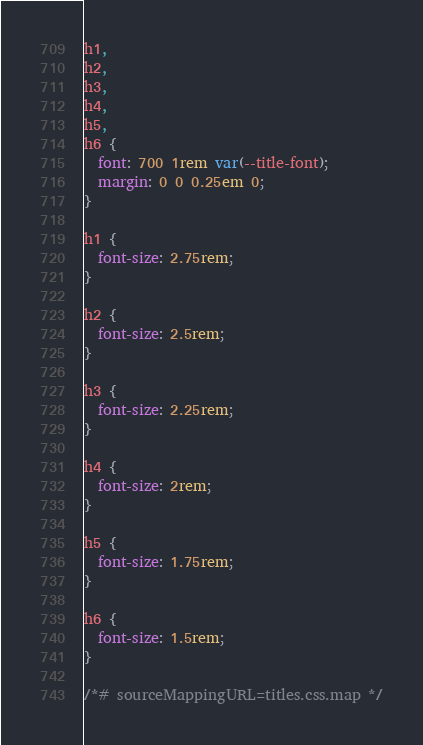<code> <loc_0><loc_0><loc_500><loc_500><_CSS_>h1,
h2,
h3,
h4,
h5,
h6 {
  font: 700 1rem var(--title-font);
  margin: 0 0 0.25em 0;
}

h1 {
  font-size: 2.75rem;
}

h2 {
  font-size: 2.5rem;
}

h3 {
  font-size: 2.25rem;
}

h4 {
  font-size: 2rem;
}

h5 {
  font-size: 1.75rem;
}

h6 {
  font-size: 1.5rem;
}

/*# sourceMappingURL=titles.css.map */</code> 